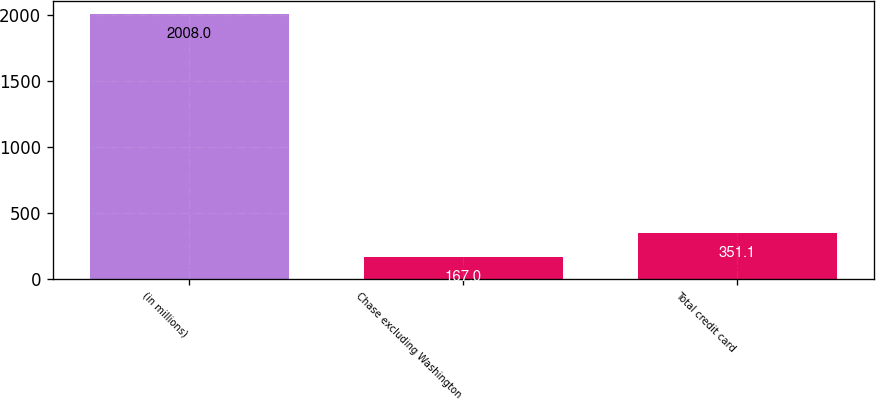<chart> <loc_0><loc_0><loc_500><loc_500><bar_chart><fcel>(in millions)<fcel>Chase excluding Washington<fcel>Total credit card<nl><fcel>2008<fcel>167<fcel>351.1<nl></chart> 